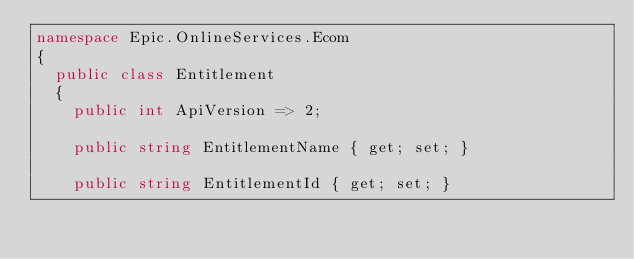Convert code to text. <code><loc_0><loc_0><loc_500><loc_500><_C#_>namespace Epic.OnlineServices.Ecom
{
	public class Entitlement
	{
		public int ApiVersion => 2;

		public string EntitlementName { get; set; }

		public string EntitlementId { get; set; }
</code> 